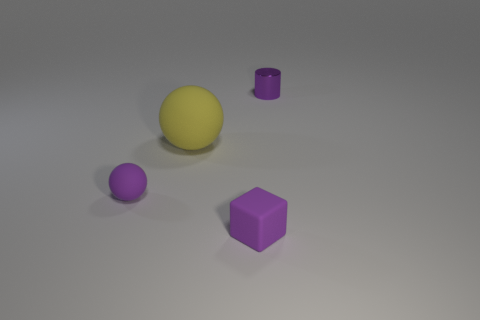Add 3 large purple spheres. How many objects exist? 7 Add 4 blue matte blocks. How many blue matte blocks exist? 4 Subtract 0 cyan cylinders. How many objects are left? 4 Subtract all small cyan blocks. Subtract all purple rubber things. How many objects are left? 2 Add 1 big things. How many big things are left? 2 